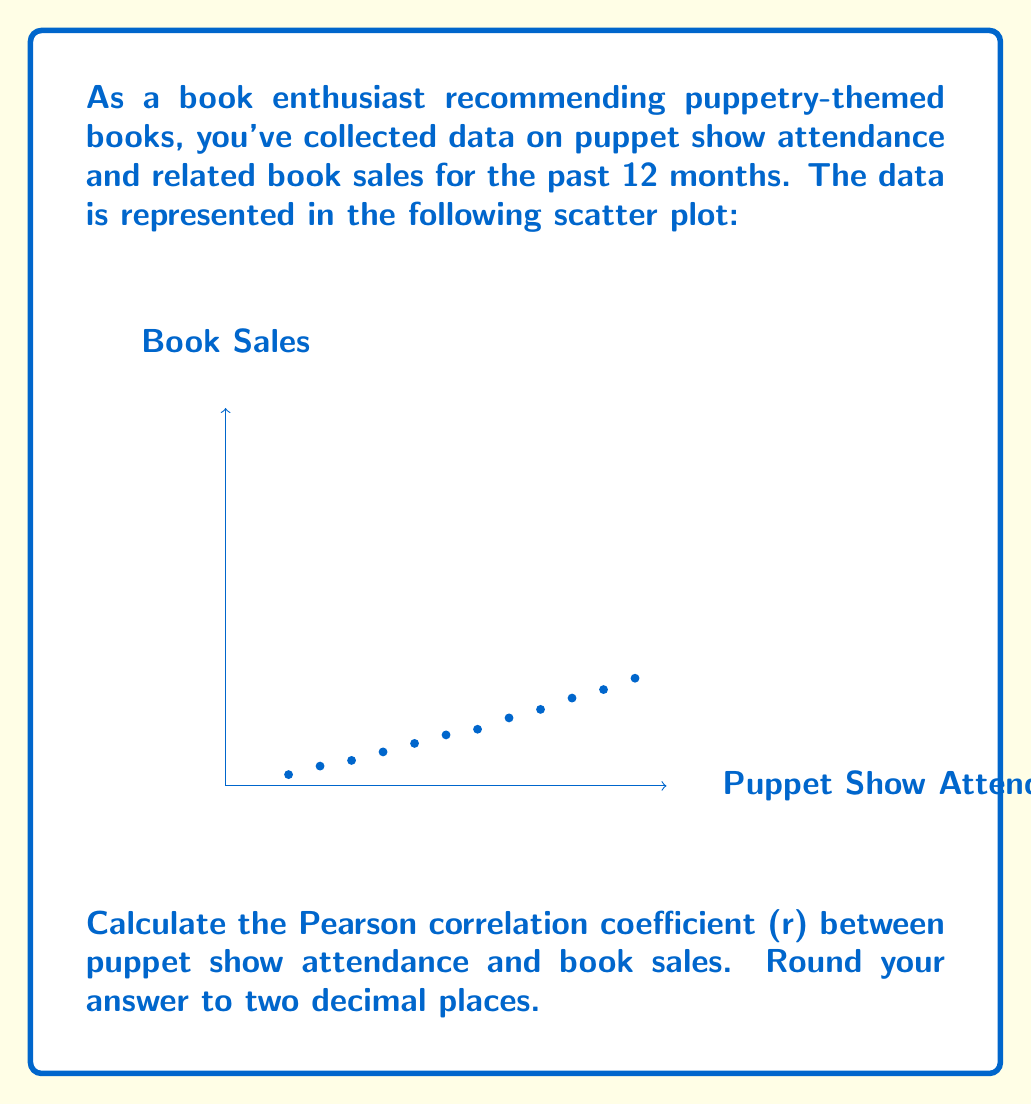Can you solve this math problem? To calculate the Pearson correlation coefficient (r), we'll use the formula:

$$ r = \frac{\sum_{i=1}^{n} (x_i - \bar{x})(y_i - \bar{y})}{\sqrt{\sum_{i=1}^{n} (x_i - \bar{x})^2} \sqrt{\sum_{i=1}^{n} (y_i - \bar{y})^2}} $$

Where:
$x_i$ = puppet show attendance
$y_i$ = book sales
$\bar{x}$ = mean of puppet show attendance
$\bar{y}$ = mean of book sales
$n$ = number of data points (12 in this case)

Step 1: Calculate the means
$\bar{x} = \frac{100 + 150 + ... + 650}{12} = 375$
$\bar{y} = \frac{20 + 35 + ... + 190}{12} = 99.58$

Step 2: Calculate $(x_i - \bar{x})$, $(y_i - \bar{y})$, $(x_i - \bar{x})^2$, $(y_i - \bar{y})^2$, and $(x_i - \bar{x})(y_i - \bar{y})$ for each data point.

Step 3: Sum up the values calculated in Step 2
$\sum (x_i - \bar{x})(y_i - \bar{y}) = 168,750$
$\sum (x_i - \bar{x})^2 = 455,625$
$\sum (y_i - \bar{y})^2 = 32,291.92$

Step 4: Apply the formula
$$ r = \frac{168,750}{\sqrt{455,625} \sqrt{32,291.92}} = 0.9938 $$

Step 5: Round to two decimal places
$r \approx 0.99$
Answer: 0.99 